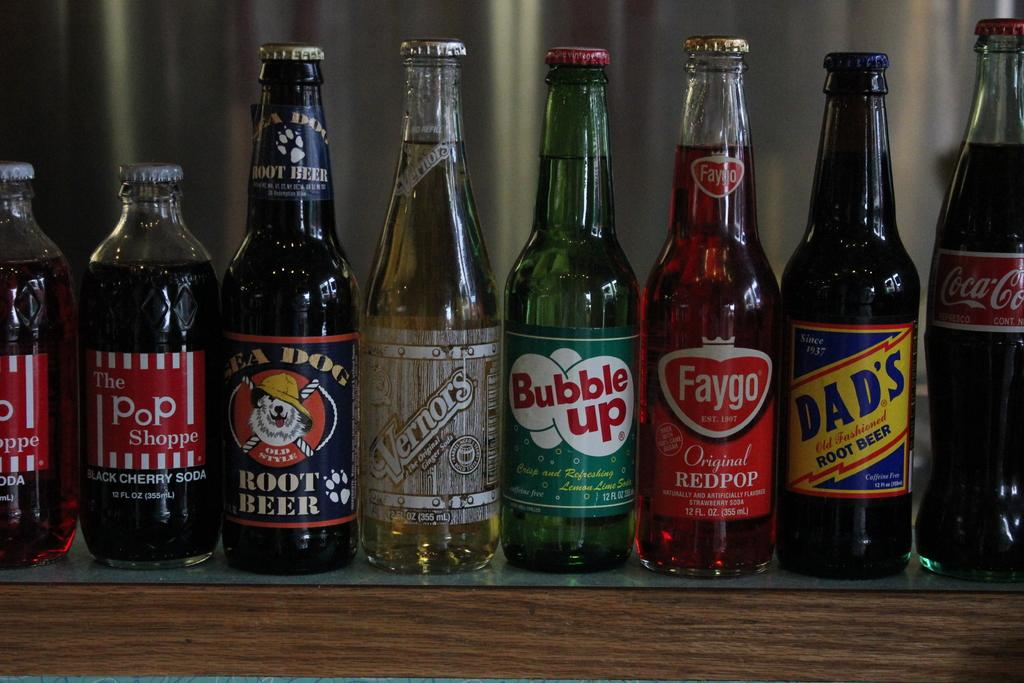What objects are visible in the image? There are bottles in the image. Where are the bottles located? The bottles are on a table. How much money is being exchanged between the trees in the image? There are no trees or money present in the image; it only features bottles on a table. 